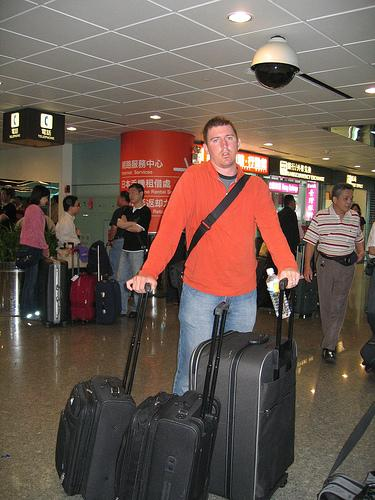What is the sentiment associated with the image? The sentiment is neutral as there are no significant emotional elements present in the image. Explain the possible purpose of the image and what is the main focal point? The purpose of the image seems to depict people and luggage within an airport setting. The main focal point is a man wearing an orange long sleeve shirt with three black suitcases. Which object in the picture has Asian writing on it? An orange pillar in the picture has Asian writing on it. Which individuals in the image exhibit unique aspects in their appearance or attire? The man wearing an orange long sleeve shirt, the woman in a pink shirt, and the man in the striped shirt with brown pants stand out. Identify the main colors present in the image. Black, orange, blue, pink, red, brown, gray, and white. What type of lighting is shown in the image? There are recessed lighting fixtures in the ceiling. Briefly describe the clothing worn by the people in the image. The people in the image are wearing orange and pink sweaters, blue jeans, striped shirts, and khaki and brown pants. Can you provide a brief caption that encompasses the main elements of the image? Airport scene with people wearing various outfits, numerous suitcases, and a pillar with Asian writing. How many pieces of luggage can you count in the image? There are nine pieces of luggage in the image. Describe the image in terms of its quality. The image has clear details, high resolution, and accurate object representation, making it a good quality image. 